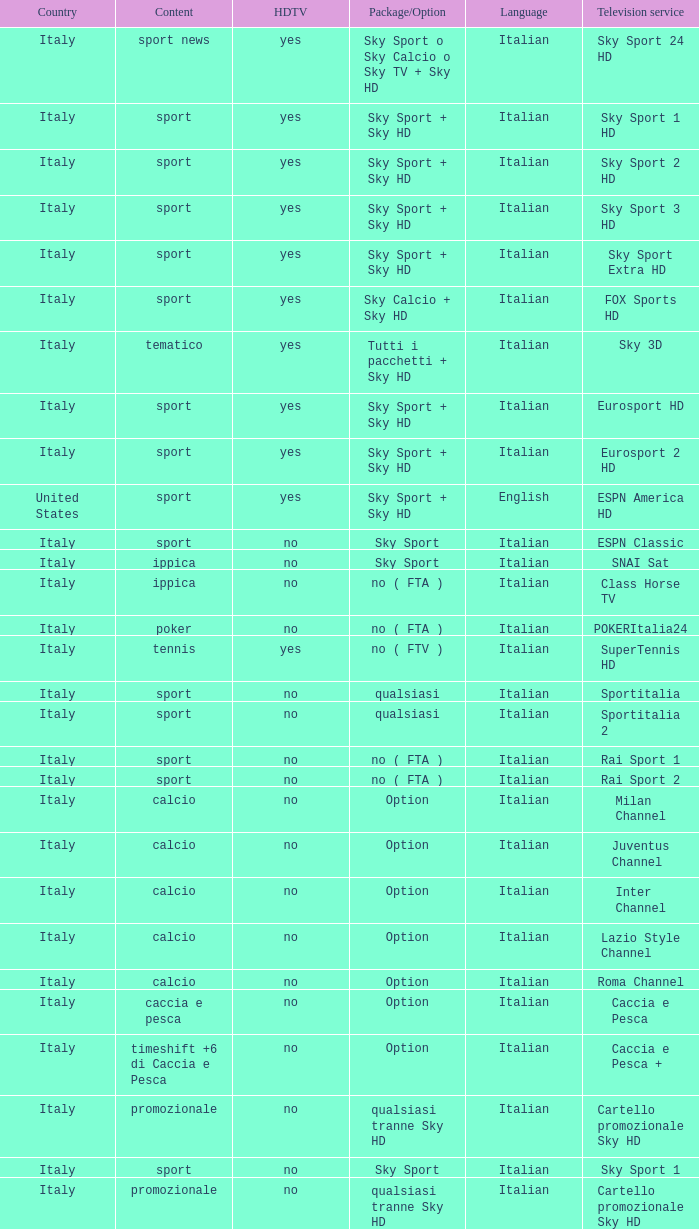What is Language, when Content is Sport, when HDTV is No, and when Television Service is ESPN America? Italian. 